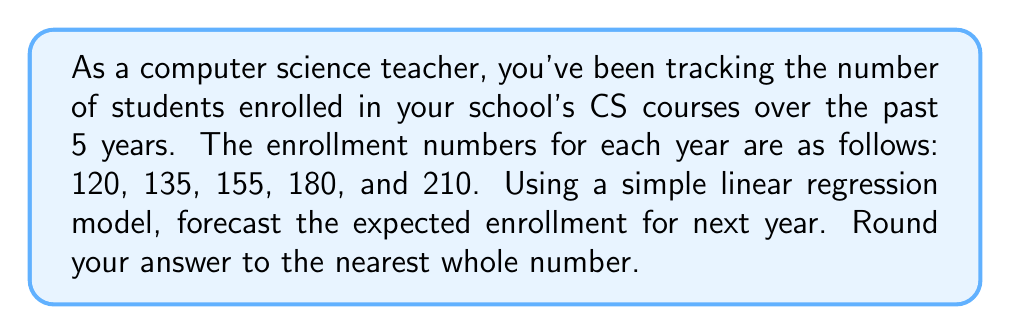Solve this math problem. To forecast the future demand for computer science courses using historical data, we'll use a simple linear regression model. This model assumes a linear trend in the data.

Steps:

1. Assign time values (x) to each year, starting with 1 for the first year:
   Year 1: 120 students
   Year 2: 135 students
   Year 3: 155 students
   Year 4: 180 students
   Year 5: 210 students

2. Calculate the means of x and y:
   $\bar{x} = \frac{1 + 2 + 3 + 4 + 5}{5} = 3$
   $\bar{y} = \frac{120 + 135 + 155 + 180 + 210}{5} = 160$

3. Calculate the slope (b) using the formula:
   $$b = \frac{\sum(x_i - \bar{x})(y_i - \bar{y})}{\sum(x_i - \bar{x})^2}$$

   $\sum(x_i - \bar{x})(y_i - \bar{y}) = (-2)(-40) + (-1)(-25) + (0)(-5) + (1)(20) + (2)(50) = 80 + 25 + 0 + 20 + 100 = 225$
   $\sum(x_i - \bar{x})^2 = (-2)^2 + (-1)^2 + 0^2 + 1^2 + 2^2 = 4 + 1 + 0 + 1 + 4 = 10$

   $b = \frac{225}{10} = 22.5$

4. Calculate the y-intercept (a) using the formula:
   $a = \bar{y} - b\bar{x} = 160 - 22.5(3) = 92.5$

5. The linear regression equation is:
   $y = 22.5x + 92.5$

6. To forecast for next year (Year 6), substitute x = 6:
   $y = 22.5(6) + 92.5 = 135 + 92.5 = 227.5$

7. Rounding to the nearest whole number:
   227.5 ≈ 228
Answer: 228 students 